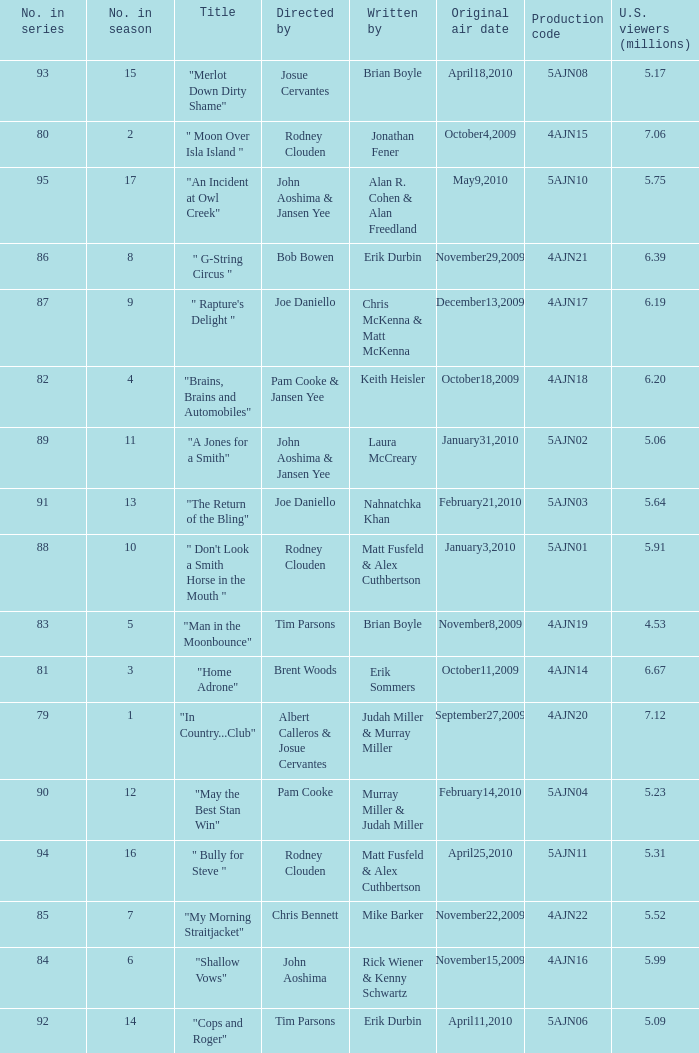Name who wrote the episode directed by  pam cooke & jansen yee Keith Heisler. 